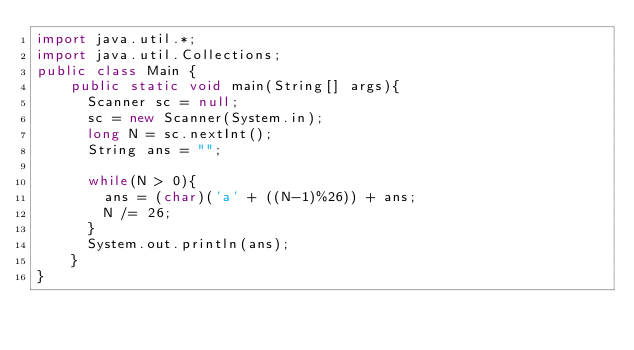<code> <loc_0><loc_0><loc_500><loc_500><_Java_>import java.util.*;
import java.util.Collections;
public class Main {
	public static void main(String[] args){	
      Scanner sc = null;
      sc = new Scanner(System.in);
      long N = sc.nextInt();
      String ans = "";
     
      while(N > 0){
        ans = (char)('a' + ((N-1)%26)) + ans;
        N /= 26;
      }
      System.out.println(ans);
    }
}</code> 